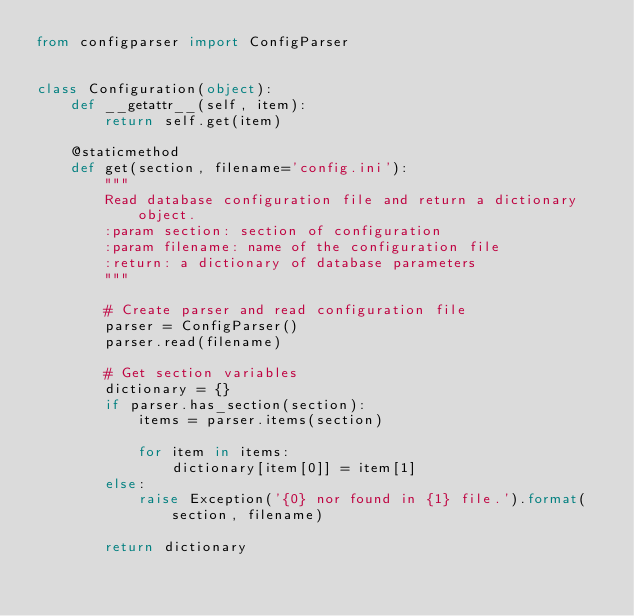Convert code to text. <code><loc_0><loc_0><loc_500><loc_500><_Python_>from configparser import ConfigParser


class Configuration(object):
    def __getattr__(self, item):
        return self.get(item)

    @staticmethod
    def get(section, filename='config.ini'):
        """
        Read database configuration file and return a dictionary object.
        :param section: section of configuration
        :param filename: name of the configuration file
        :return: a dictionary of database parameters
        """

        # Create parser and read configuration file
        parser = ConfigParser()
        parser.read(filename)

        # Get section variables
        dictionary = {}
        if parser.has_section(section):
            items = parser.items(section)

            for item in items:
                dictionary[item[0]] = item[1]
        else:
            raise Exception('{0} nor found in {1} file.').format(section, filename)

        return dictionary
</code> 